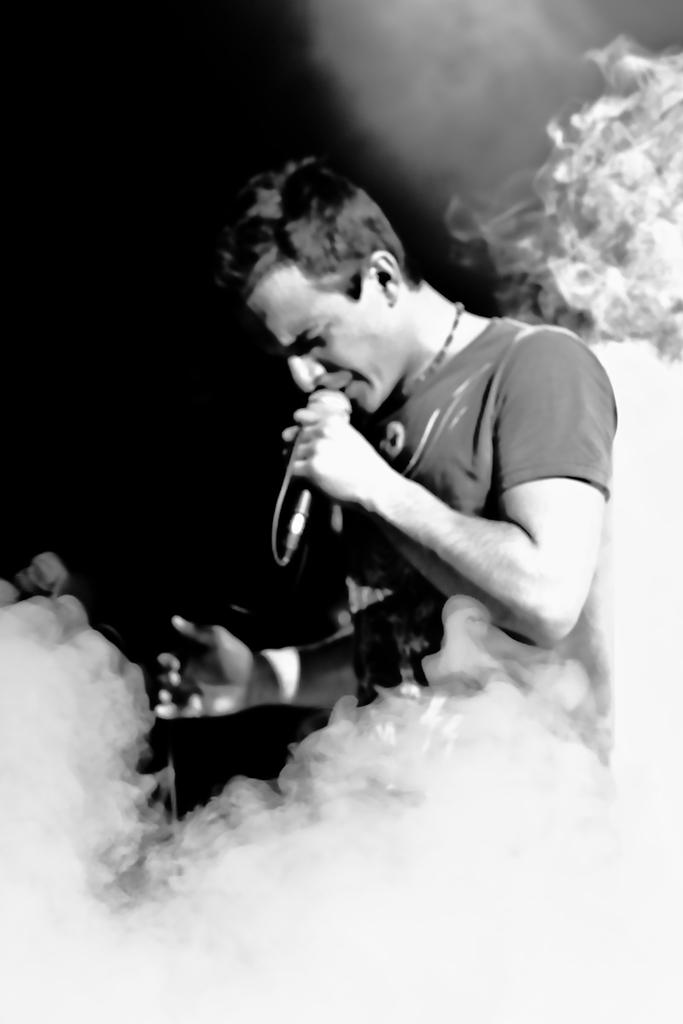Who is the main subject in the image? There is a man in the image. What is the man doing in the image? The man is singing. What object is the man holding in the image? The man is holding a microphone. What type of clothing is the man wearing in the image? The man is wearing a t-shirt. What type of vegetable is the man eating in the image? There is no vegetable present in the image; the man is singing and holding a microphone. Can you tell me how the man is interacting with the zoo in the image? There is no zoo present in the image; the man is singing and holding a microphone. 